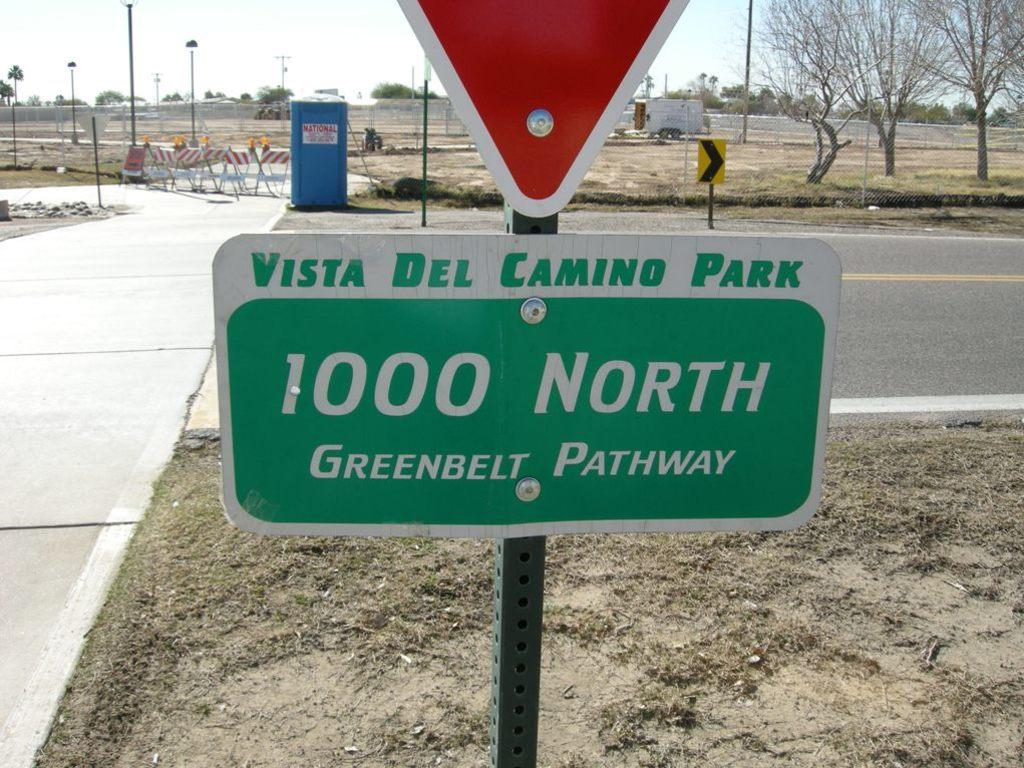<image>
Provide a brief description of the given image. Sign that says Vista Del Camino Park 1000 North Greenbelt Pathway 